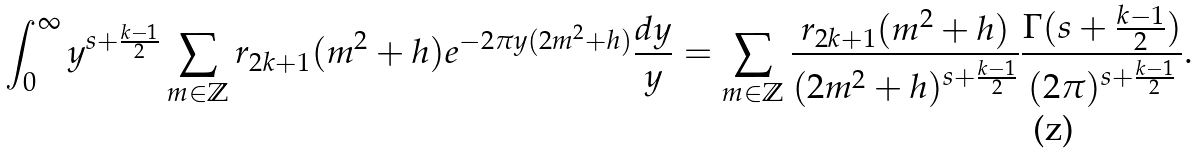<formula> <loc_0><loc_0><loc_500><loc_500>\int _ { 0 } ^ { \infty } y ^ { s + \frac { k - 1 } { 2 } } \sum _ { m \in \mathbb { Z } } r _ { 2 k + 1 } ( m ^ { 2 } + h ) e ^ { - 2 \pi y ( 2 m ^ { 2 } + h ) } \frac { d y } { y } = \sum _ { m \in \mathbb { Z } } \frac { r _ { 2 k + 1 } ( m ^ { 2 } + h ) } { ( 2 m ^ { 2 } + h ) ^ { s + \frac { k - 1 } { 2 } } } \frac { \Gamma ( s + \frac { k - 1 } { 2 } ) } { ( 2 \pi ) ^ { s + \frac { k - 1 } { 2 } } } .</formula> 